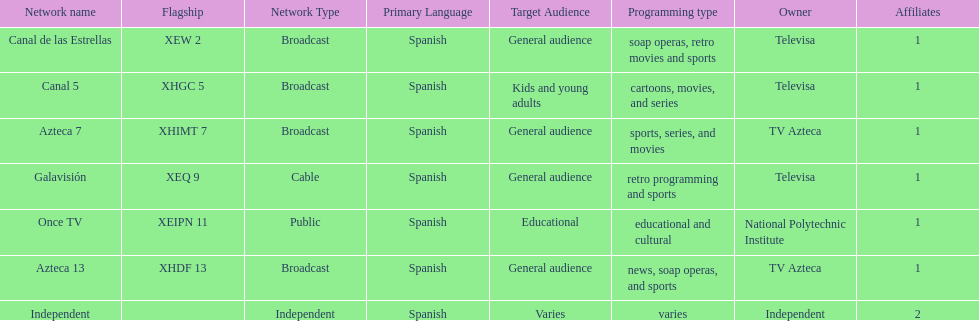What is the only network owned by national polytechnic institute? Once TV. 